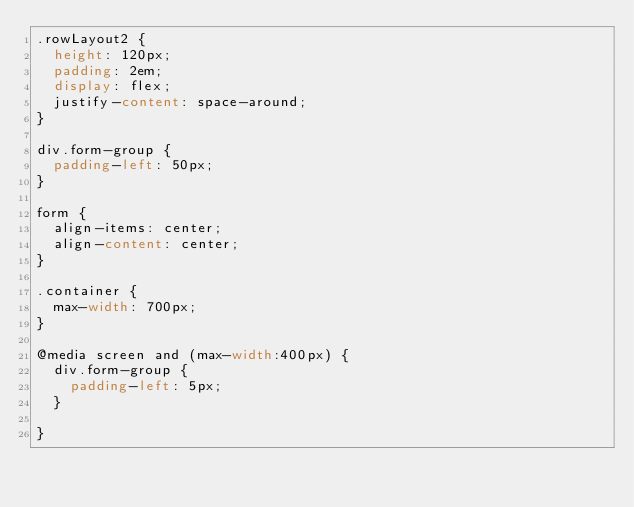<code> <loc_0><loc_0><loc_500><loc_500><_CSS_>.rowLayout2 {
	height: 120px;
	padding: 2em;
	display: flex;
	justify-content: space-around;
}

div.form-group {
	padding-left: 50px;
}

form {
	align-items: center;
	align-content: center;
}

.container {
	max-width: 700px;
}

@media screen and (max-width:400px) {
	div.form-group {
		padding-left: 5px;
	}
	
}</code> 